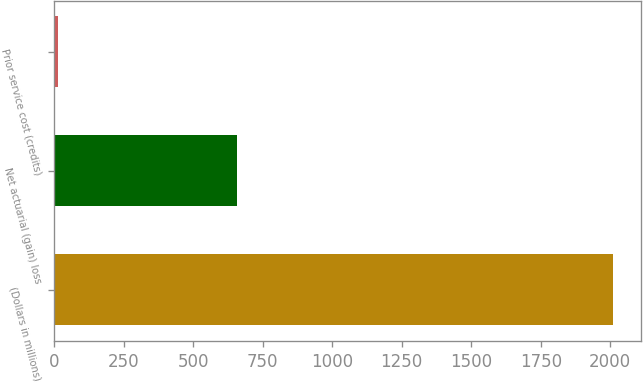Convert chart to OTSL. <chart><loc_0><loc_0><loc_500><loc_500><bar_chart><fcel>(Dollars in millions)<fcel>Net actuarial (gain) loss<fcel>Prior service cost (credits)<nl><fcel>2010<fcel>656<fcel>15<nl></chart> 